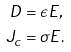<formula> <loc_0><loc_0><loc_500><loc_500>D & = \epsilon E , \\ J _ { c } & = \sigma E .</formula> 